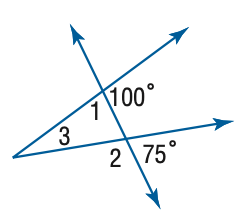Question: Find the measure of \angle 2 in the figure.
Choices:
A. 105
B. 110
C. 115
D. 120
Answer with the letter. Answer: A Question: Find the measure of \angle 3 in the figure.
Choices:
A. 10
B. 15
C. 20
D. 25
Answer with the letter. Answer: D Question: Find the measure of \angle 1 in the figure.
Choices:
A. 75
B. 80
C. 85
D. 90
Answer with the letter. Answer: B 